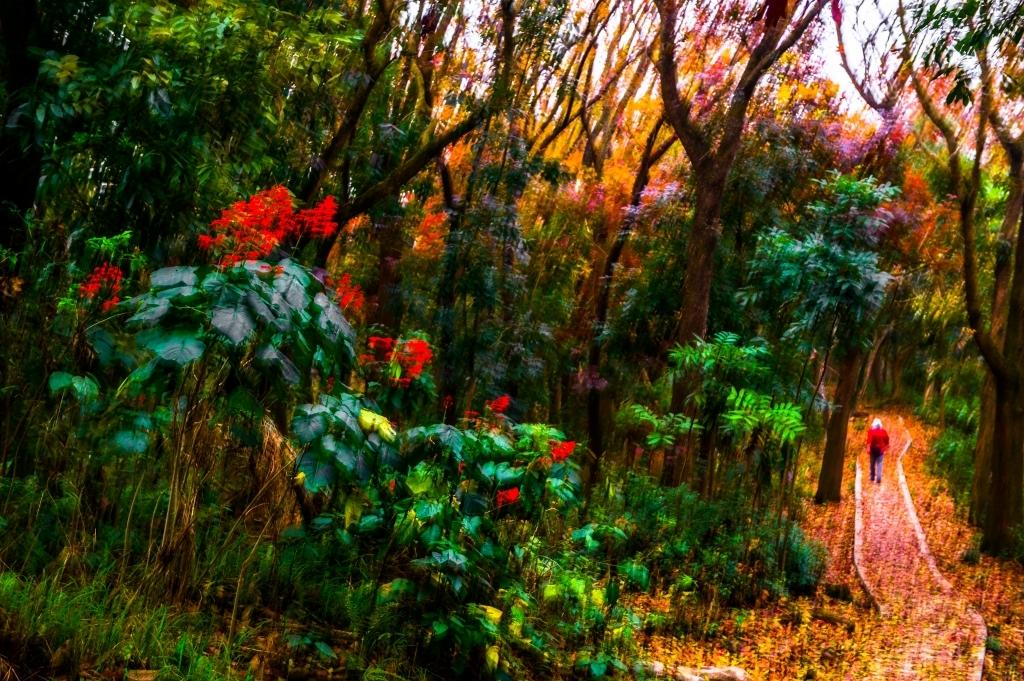What type of living organisms can be seen in the image? Plants can be seen in the image. What is the person in the image doing? A person is walking in the image. What else can be found on the ground in the image? Dry leaves are present in the image. What is visible in the background of the image? Trees and the sky are visible in the background of the image. What type of insurance policy is being discussed by the person walking in the image? There is no indication in the image that the person is discussing any type of insurance policy. 